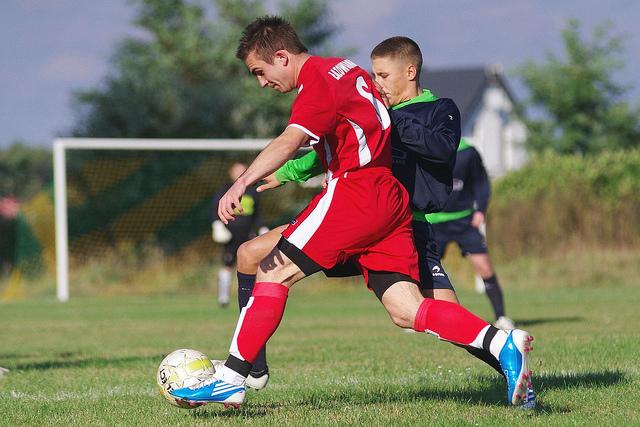What game are they playing?
Be succinct. Soccer. Which person is closer to kicking the ball?
Short answer required. Red. Why are there only two men going after the ball?
Concise answer only. Yes. 